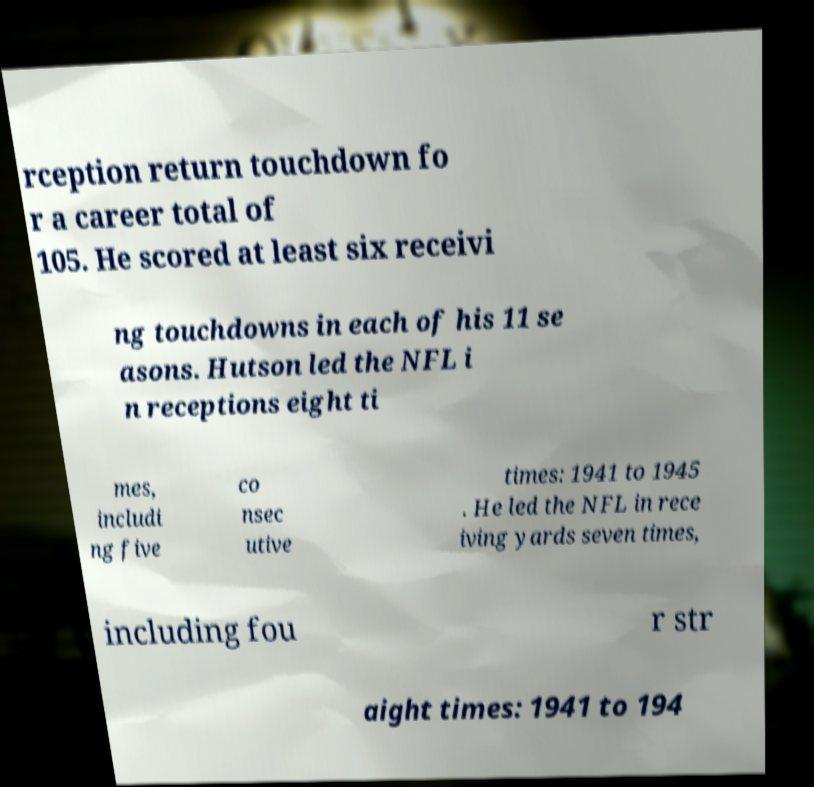For documentation purposes, I need the text within this image transcribed. Could you provide that? rception return touchdown fo r a career total of 105. He scored at least six receivi ng touchdowns in each of his 11 se asons. Hutson led the NFL i n receptions eight ti mes, includi ng five co nsec utive times: 1941 to 1945 . He led the NFL in rece iving yards seven times, including fou r str aight times: 1941 to 194 